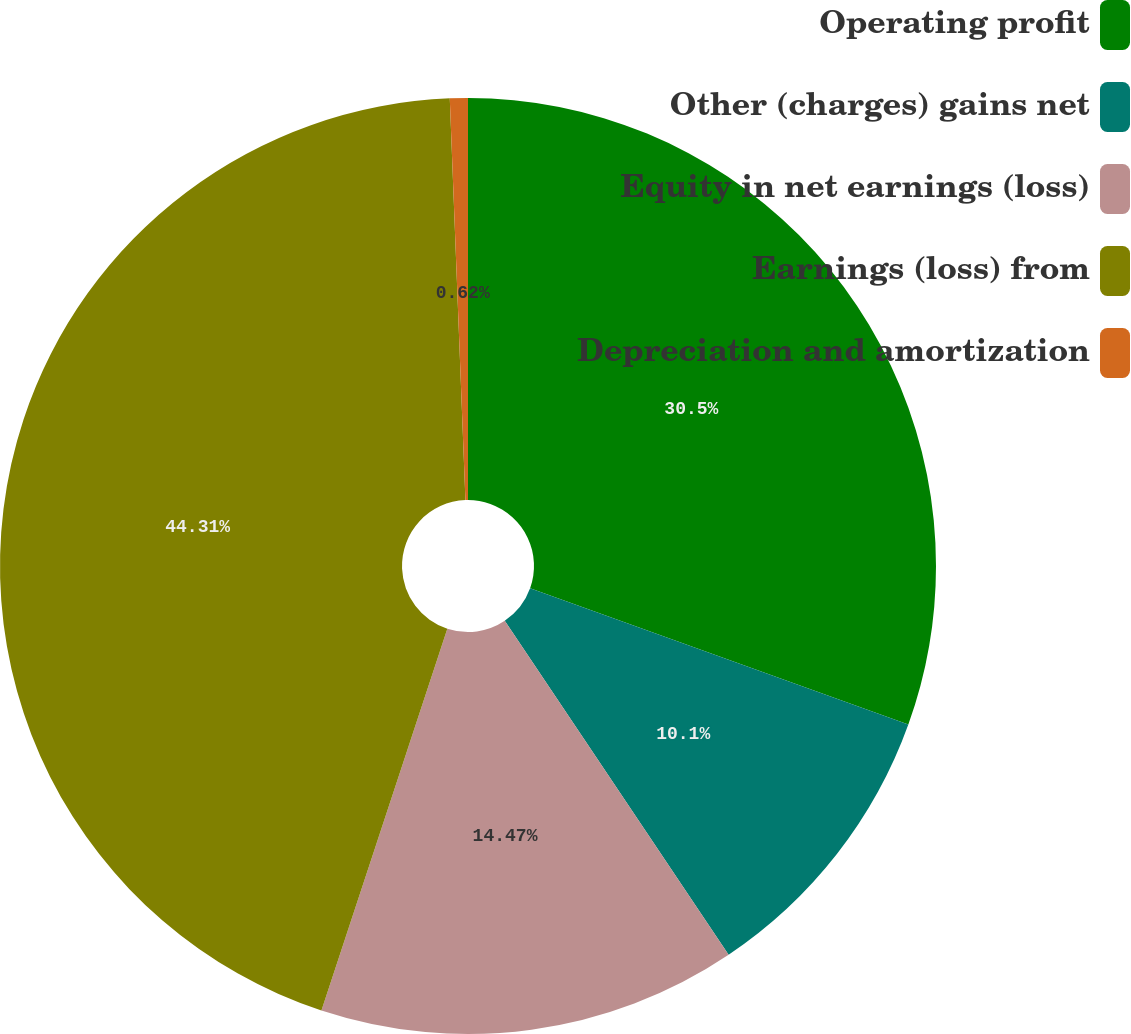Convert chart to OTSL. <chart><loc_0><loc_0><loc_500><loc_500><pie_chart><fcel>Operating profit<fcel>Other (charges) gains net<fcel>Equity in net earnings (loss)<fcel>Earnings (loss) from<fcel>Depreciation and amortization<nl><fcel>30.5%<fcel>10.1%<fcel>14.47%<fcel>44.31%<fcel>0.62%<nl></chart> 